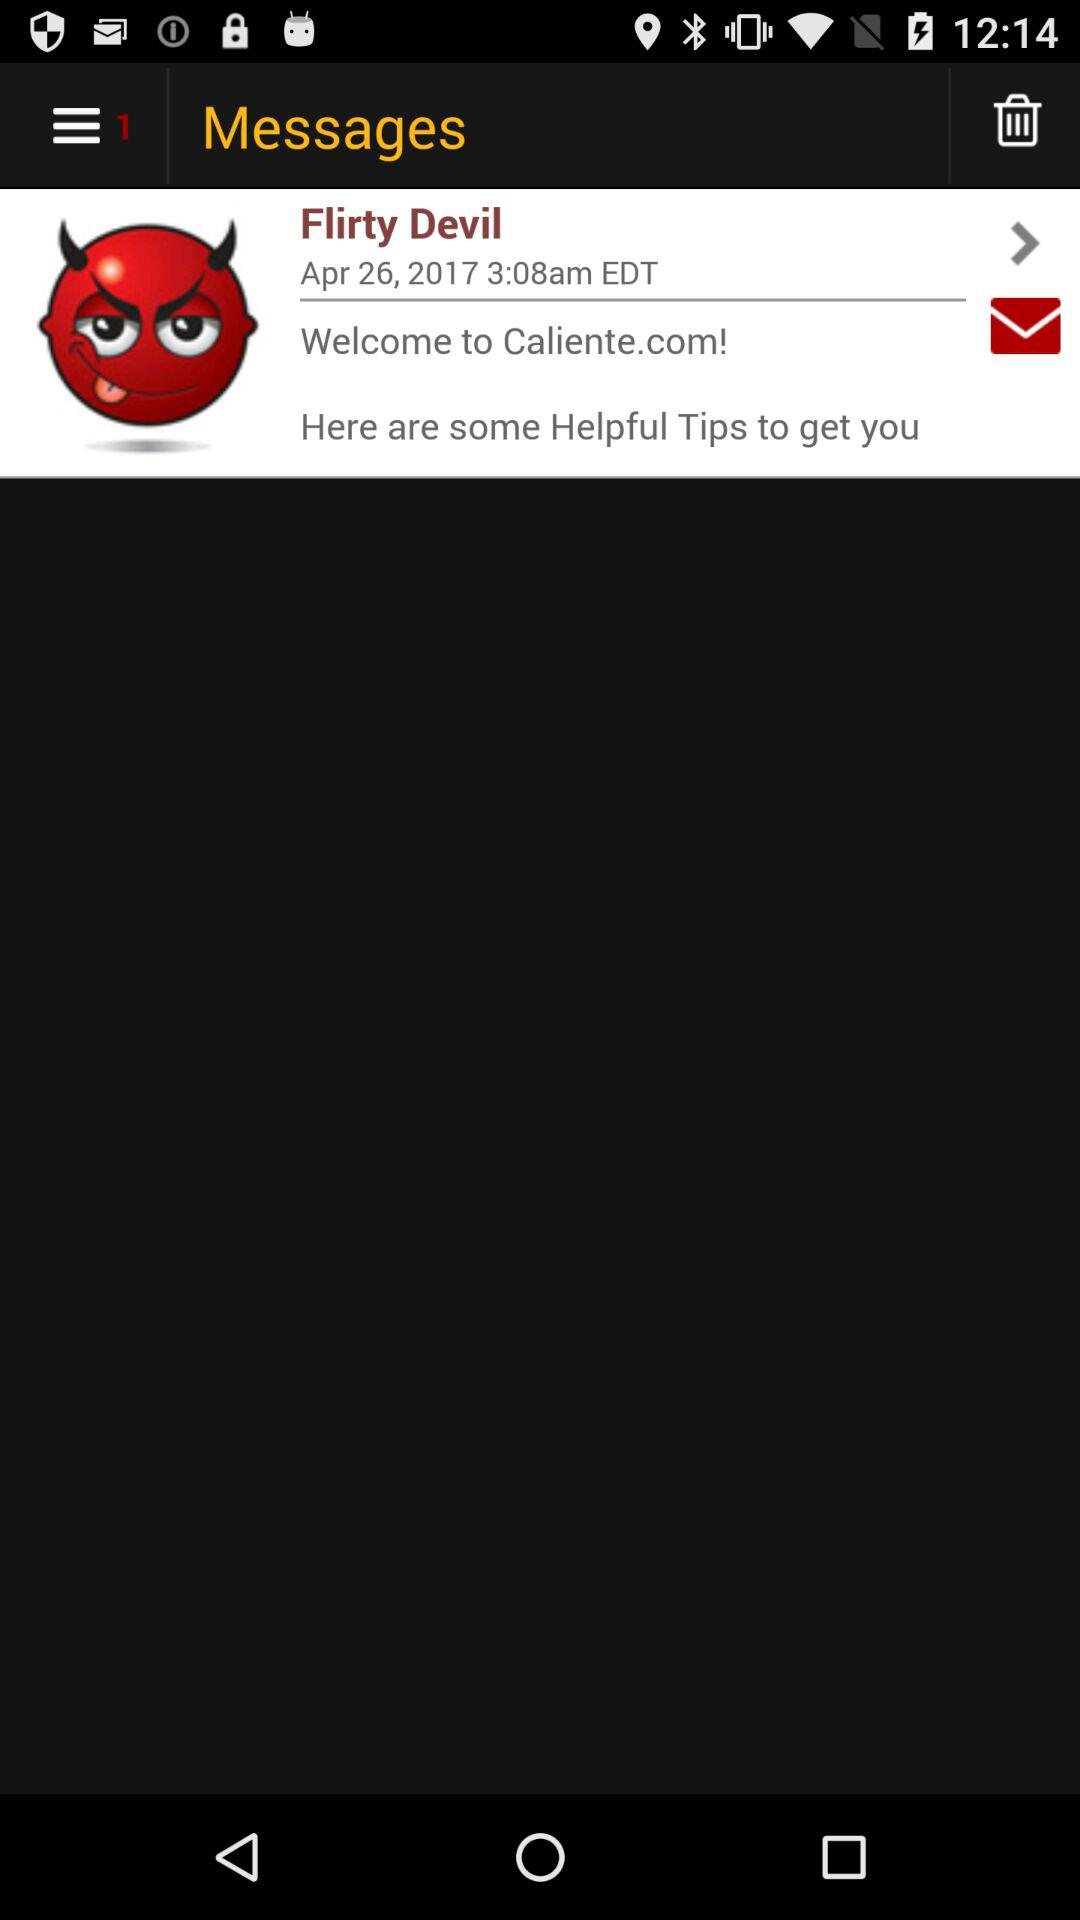When was the message received? The message was received on April 26, 2017 at 3:08 a.m. EDT. 